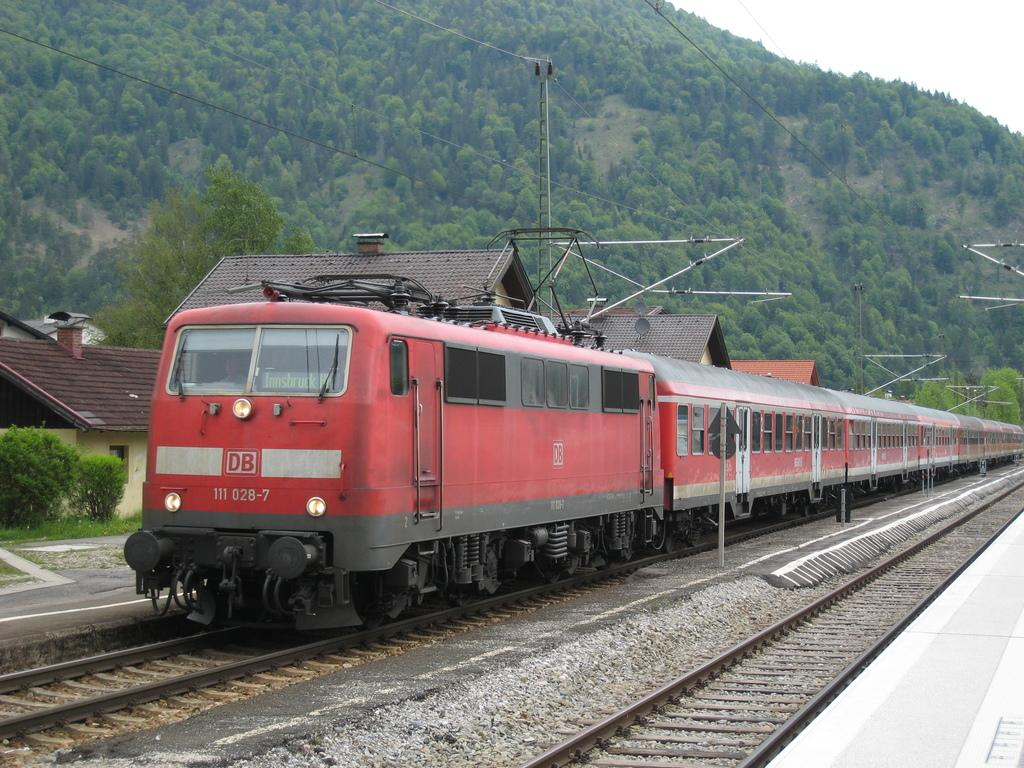<image>
Describe the image concisely. A train chugs along with DB displayed on its first car. 